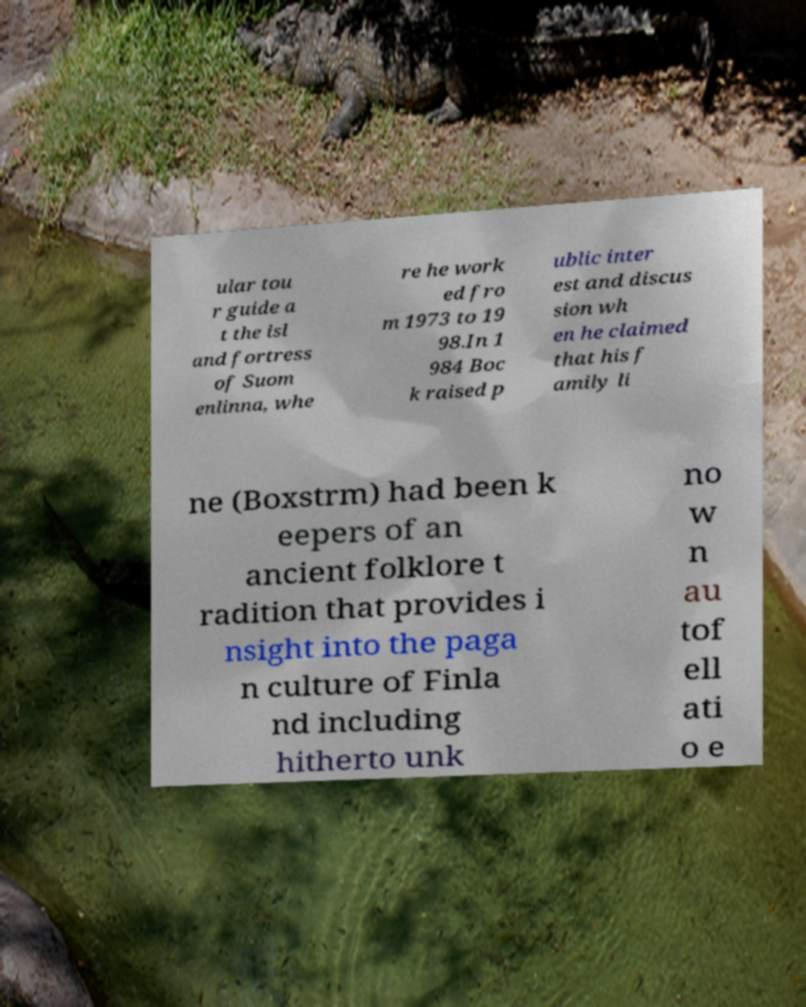There's text embedded in this image that I need extracted. Can you transcribe it verbatim? ular tou r guide a t the isl and fortress of Suom enlinna, whe re he work ed fro m 1973 to 19 98.In 1 984 Boc k raised p ublic inter est and discus sion wh en he claimed that his f amily li ne (Boxstrm) had been k eepers of an ancient folklore t radition that provides i nsight into the paga n culture of Finla nd including hitherto unk no w n au tof ell ati o e 